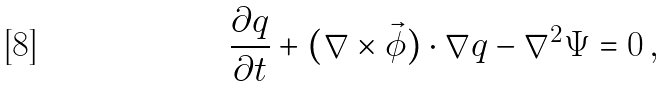<formula> <loc_0><loc_0><loc_500><loc_500>\frac { \partial q } { \partial t } + ( \nabla \times { \vec { \phi } } ) \cdot \nabla q - \nabla ^ { 2 } \Psi = 0 \, ,</formula> 